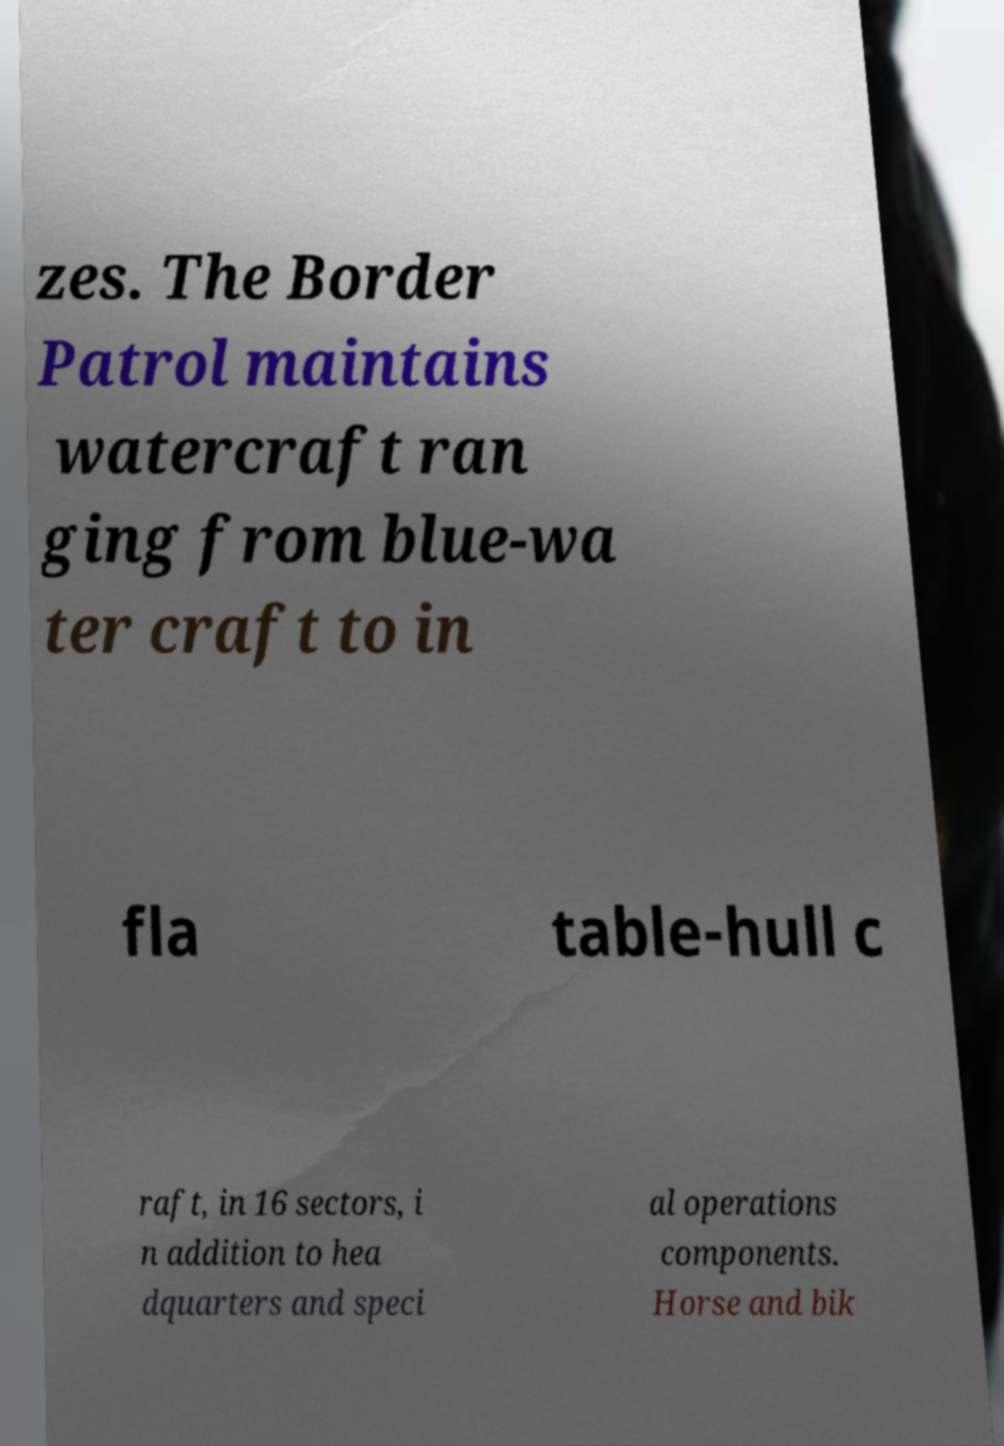Please read and relay the text visible in this image. What does it say? zes. The Border Patrol maintains watercraft ran ging from blue-wa ter craft to in fla table-hull c raft, in 16 sectors, i n addition to hea dquarters and speci al operations components. Horse and bik 